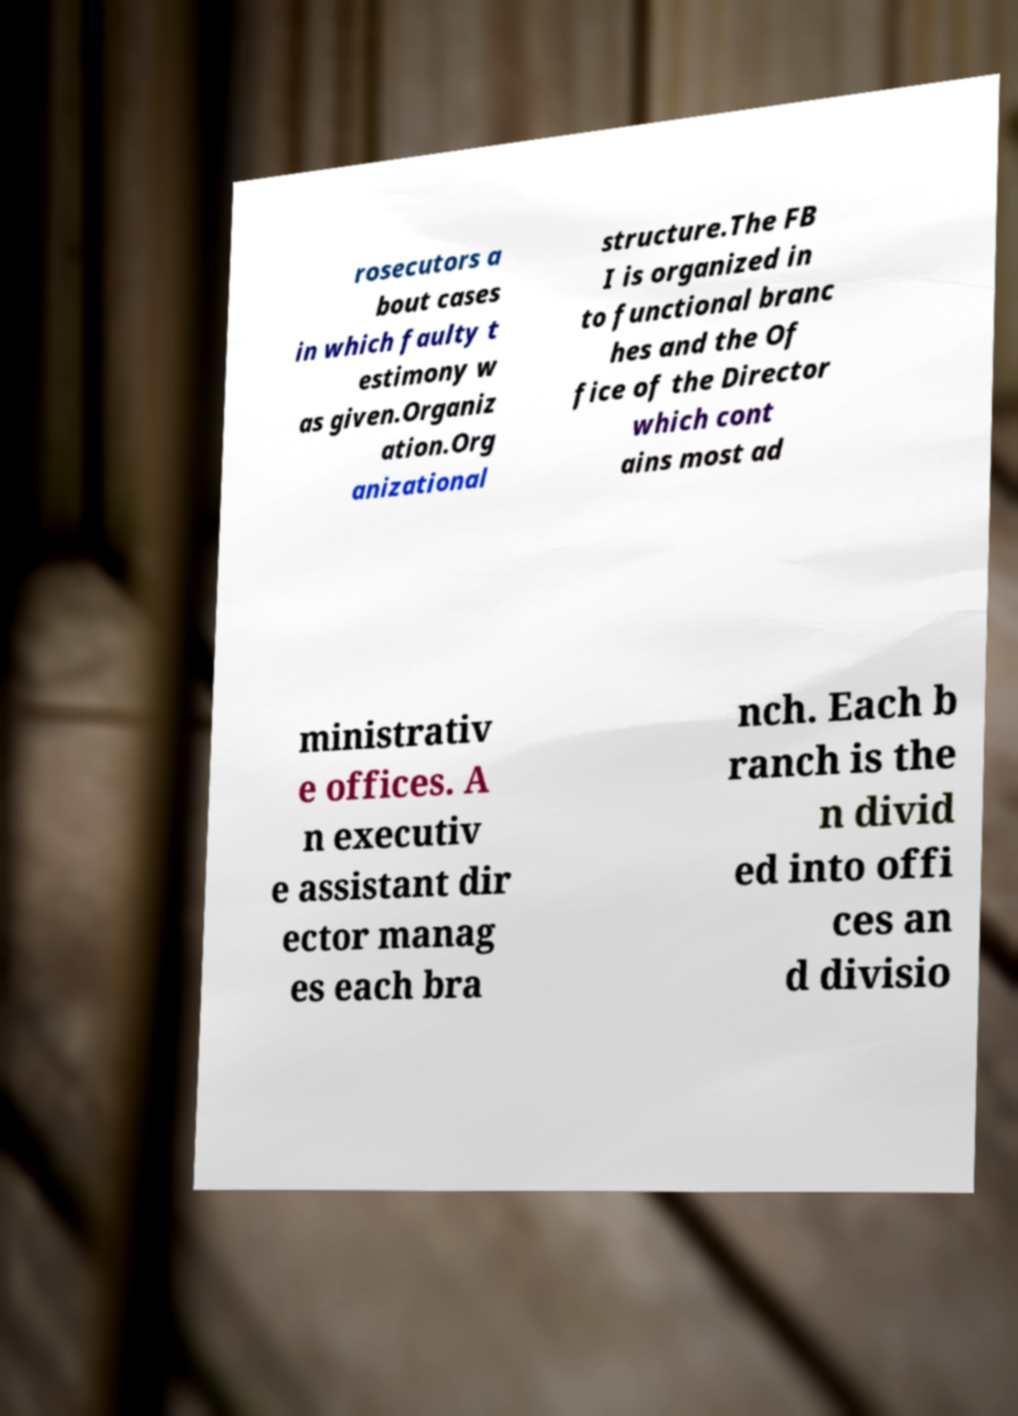There's text embedded in this image that I need extracted. Can you transcribe it verbatim? rosecutors a bout cases in which faulty t estimony w as given.Organiz ation.Org anizational structure.The FB I is organized in to functional branc hes and the Of fice of the Director which cont ains most ad ministrativ e offices. A n executiv e assistant dir ector manag es each bra nch. Each b ranch is the n divid ed into offi ces an d divisio 